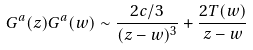<formula> <loc_0><loc_0><loc_500><loc_500>G ^ { a } ( z ) G ^ { a } ( w ) \sim \frac { 2 c / 3 } { ( z - w ) ^ { 3 } } + \frac { 2 T ( w ) } { z - w }</formula> 